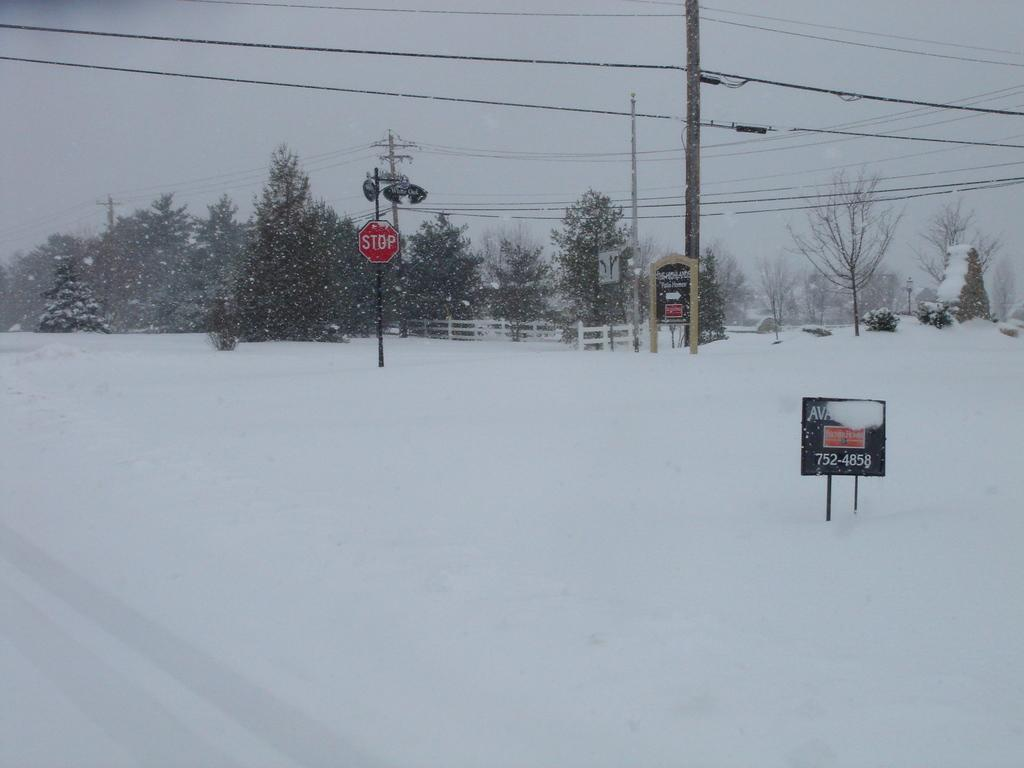What type of sign is present in the image? There is a caution board in the image. What natural elements can be seen in the image? Trees are visible in the image. What man-made structures are present in the image? Electric poles are present in the image. What is the setting of the image? The image is set on a snowy landscape. What part of the natural environment is visible in the image? The sky is visible in the image. What type of dinner is being served in the image? There is no dinner present in the image; it features a caution board, trees, electric poles, a snowy landscape, and the sky. What is the texture of the caution board in the image? The texture of the caution board cannot be determined from the image alone, as it is a two-dimensional representation. 